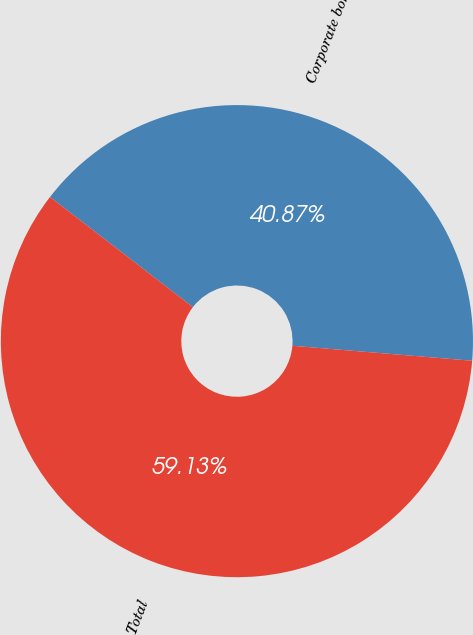<chart> <loc_0><loc_0><loc_500><loc_500><pie_chart><fcel>Corporate bonds (1)<fcel>Total<nl><fcel>40.87%<fcel>59.13%<nl></chart> 